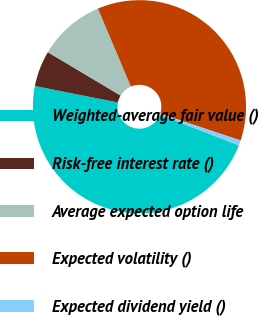<chart> <loc_0><loc_0><loc_500><loc_500><pie_chart><fcel>Weighted-average fair value ()<fcel>Risk-free interest rate ()<fcel>Average expected option life<fcel>Expected volatility ()<fcel>Expected dividend yield ()<nl><fcel>47.22%<fcel>5.43%<fcel>10.08%<fcel>36.49%<fcel>0.78%<nl></chart> 